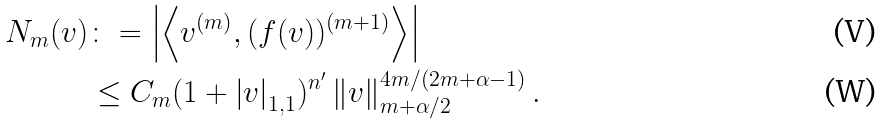<formula> <loc_0><loc_0><loc_500><loc_500>N _ { m } ( v ) & \colon = \left | \left \langle v ^ { ( m ) } , ( f ( v ) ) ^ { ( m + 1 ) } \right \rangle \right | \\ & \leq C _ { m } ( 1 + \left | v \right | _ { 1 , 1 } ) ^ { n ^ { \prime } } \left \| v \right \| _ { m + \alpha / 2 } ^ { 4 m / ( 2 m + \alpha - 1 ) } .</formula> 